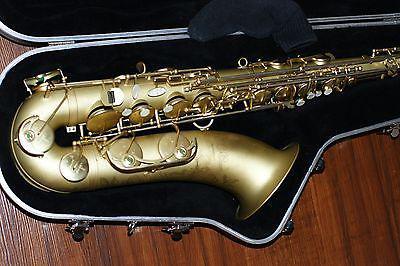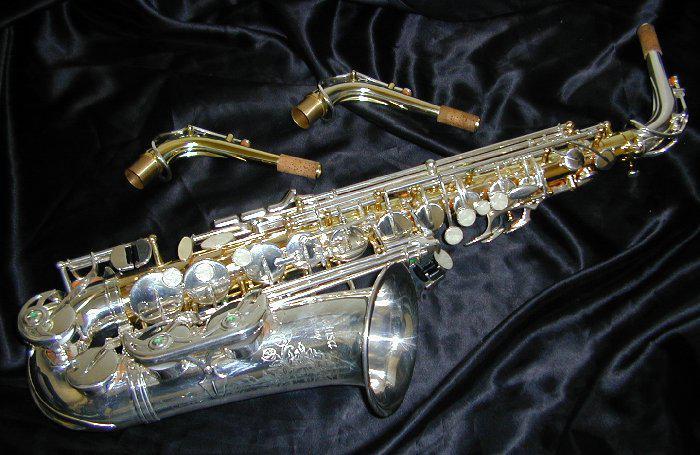The first image is the image on the left, the second image is the image on the right. Given the left and right images, does the statement "An image shows a saxophone displayed with its open, black-lined case." hold true? Answer yes or no. Yes. The first image is the image on the left, the second image is the image on the right. For the images shown, is this caption "One saxophone has two extra mouth pieces beside it and one saxophone is shown with a black lined case." true? Answer yes or no. Yes. 